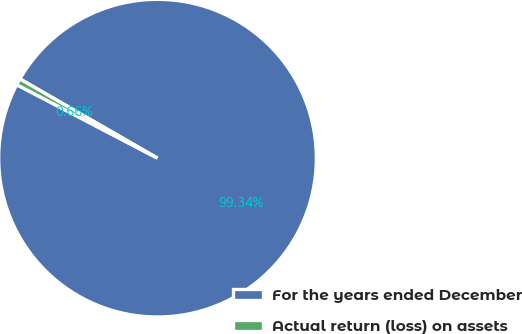<chart> <loc_0><loc_0><loc_500><loc_500><pie_chart><fcel>For the years ended December<fcel>Actual return (loss) on assets<nl><fcel>99.34%<fcel>0.66%<nl></chart> 